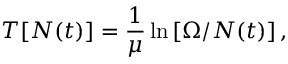<formula> <loc_0><loc_0><loc_500><loc_500>T [ N ( t ) ] = \frac { 1 } { \mu } \ln \left [ \Omega / N ( t ) \right ] ,</formula> 